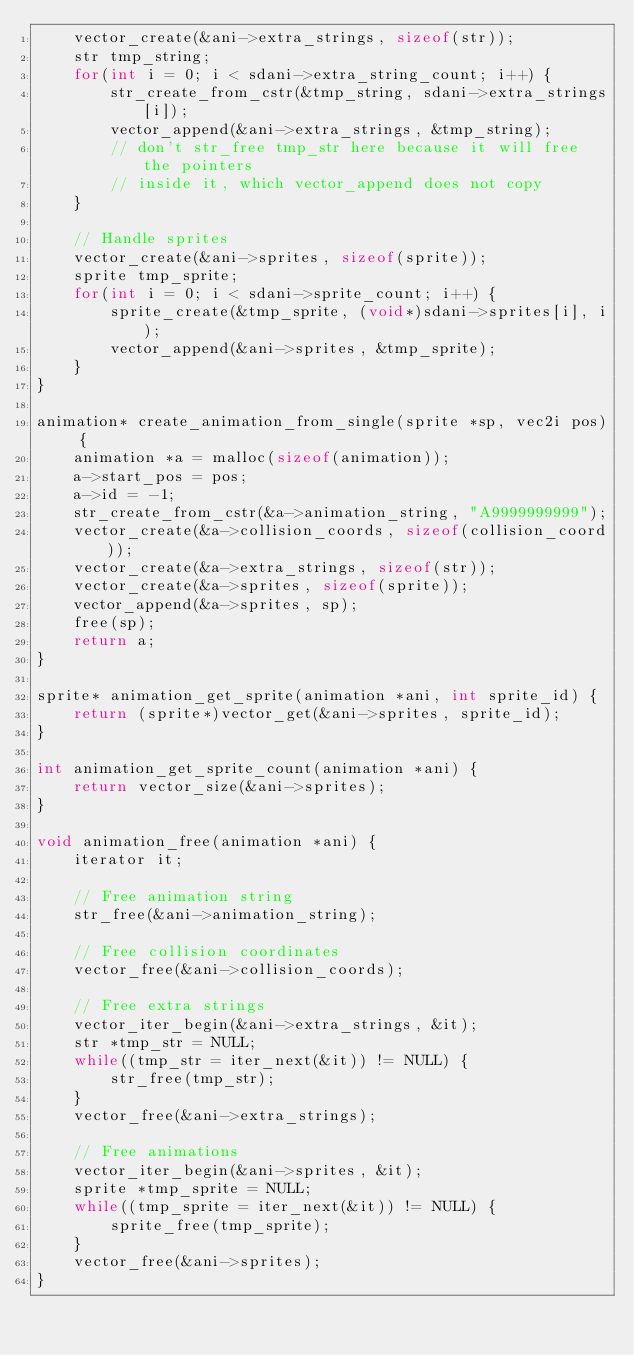<code> <loc_0><loc_0><loc_500><loc_500><_C_>    vector_create(&ani->extra_strings, sizeof(str));
    str tmp_string;
    for(int i = 0; i < sdani->extra_string_count; i++) {
        str_create_from_cstr(&tmp_string, sdani->extra_strings[i]);
        vector_append(&ani->extra_strings, &tmp_string);
        // don't str_free tmp_str here because it will free the pointers
        // inside it, which vector_append does not copy
    }

    // Handle sprites
    vector_create(&ani->sprites, sizeof(sprite));
    sprite tmp_sprite;
    for(int i = 0; i < sdani->sprite_count; i++) {
        sprite_create(&tmp_sprite, (void*)sdani->sprites[i], i);
        vector_append(&ani->sprites, &tmp_sprite);
    }
}

animation* create_animation_from_single(sprite *sp, vec2i pos) {
    animation *a = malloc(sizeof(animation));
    a->start_pos = pos;
    a->id = -1;
    str_create_from_cstr(&a->animation_string, "A9999999999");
    vector_create(&a->collision_coords, sizeof(collision_coord));
    vector_create(&a->extra_strings, sizeof(str));
    vector_create(&a->sprites, sizeof(sprite));
    vector_append(&a->sprites, sp);
    free(sp);
    return a;
}

sprite* animation_get_sprite(animation *ani, int sprite_id) {
    return (sprite*)vector_get(&ani->sprites, sprite_id);
}

int animation_get_sprite_count(animation *ani) {
    return vector_size(&ani->sprites);
}

void animation_free(animation *ani) {
    iterator it;

    // Free animation string
    str_free(&ani->animation_string);

    // Free collision coordinates
    vector_free(&ani->collision_coords);

    // Free extra strings
    vector_iter_begin(&ani->extra_strings, &it);
    str *tmp_str = NULL;
    while((tmp_str = iter_next(&it)) != NULL) {
        str_free(tmp_str);
    }
    vector_free(&ani->extra_strings);

    // Free animations
    vector_iter_begin(&ani->sprites, &it);
    sprite *tmp_sprite = NULL;
    while((tmp_sprite = iter_next(&it)) != NULL) {
        sprite_free(tmp_sprite);
    }
    vector_free(&ani->sprites);
}
</code> 